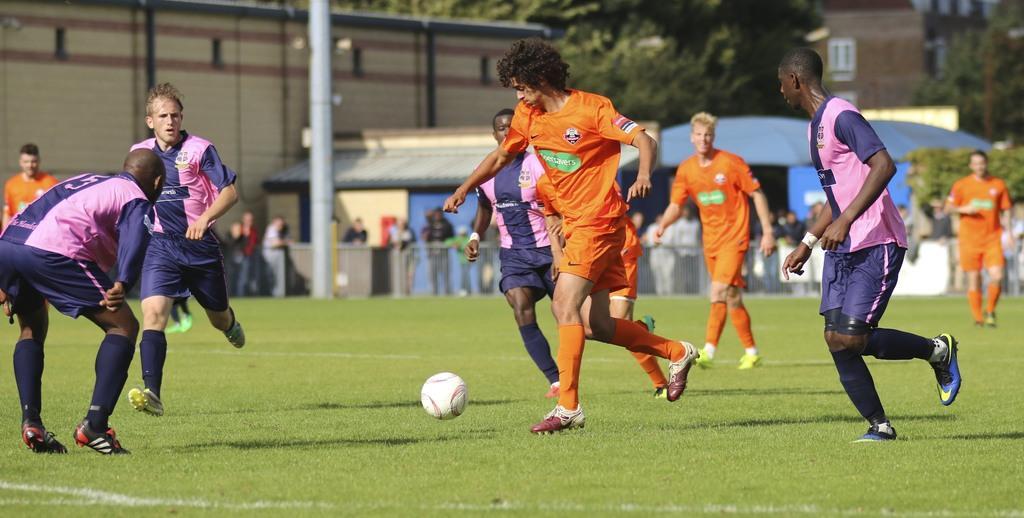Could you give a brief overview of what you see in this image? In this image there is grass. There is a ball. There are people playing. There are buildings in the background. There are people in the background. 